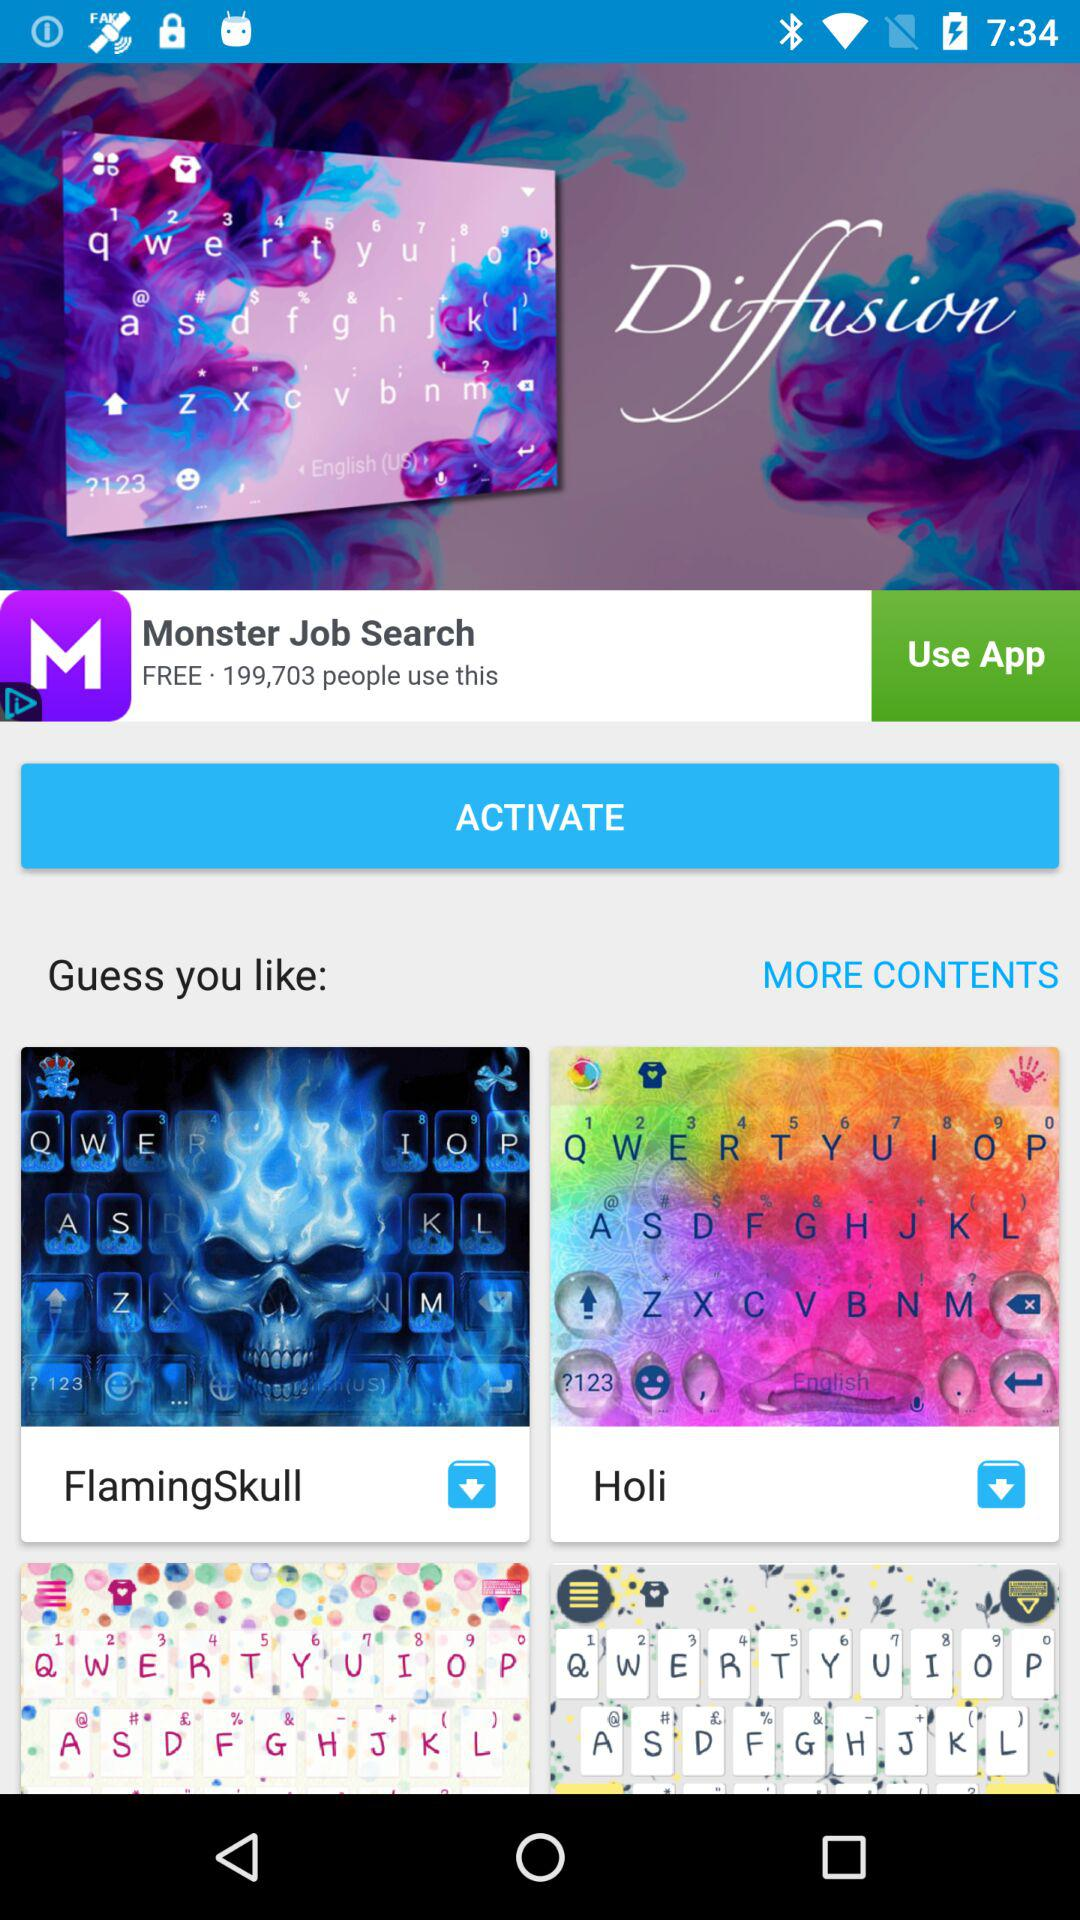What is the cost of the "Monster Job Search" application? the cost is "free". 